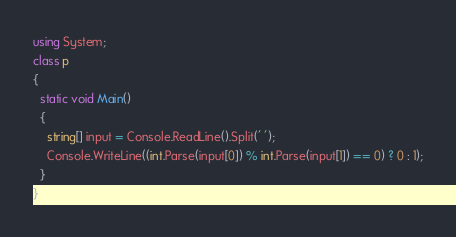<code> <loc_0><loc_0><loc_500><loc_500><_C#_>using System;
class p
{
  static void Main()
  {
    string[] input = Console.ReadLine().Split(' ');
    Console.WriteLine((int.Parse(input[0]) % int.Parse(input[1]) == 0) ? 0 : 1);
  }
}
</code> 